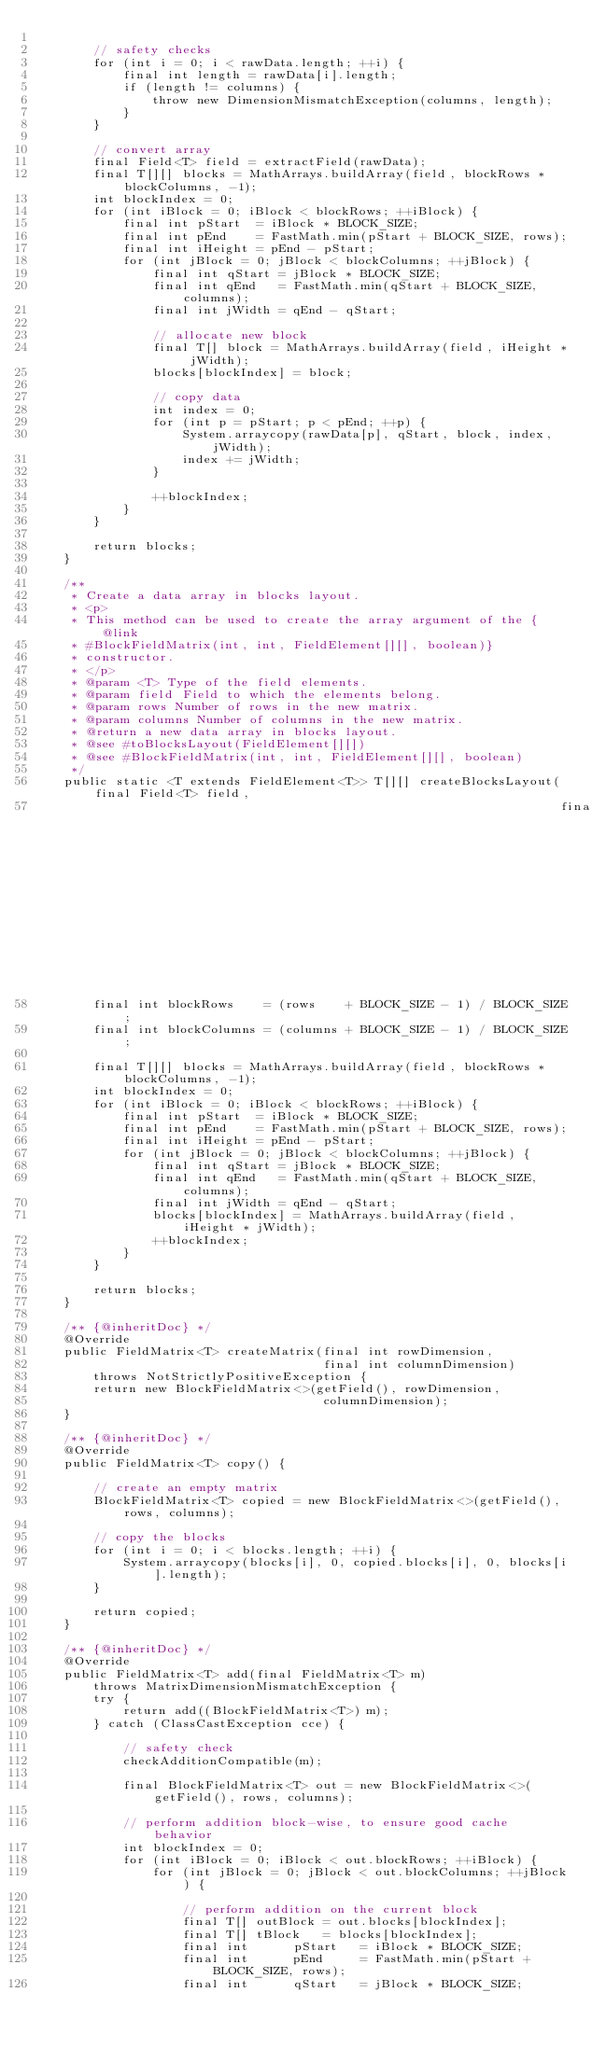<code> <loc_0><loc_0><loc_500><loc_500><_Java_>
        // safety checks
        for (int i = 0; i < rawData.length; ++i) {
            final int length = rawData[i].length;
            if (length != columns) {
                throw new DimensionMismatchException(columns, length);
            }
        }

        // convert array
        final Field<T> field = extractField(rawData);
        final T[][] blocks = MathArrays.buildArray(field, blockRows * blockColumns, -1);
        int blockIndex = 0;
        for (int iBlock = 0; iBlock < blockRows; ++iBlock) {
            final int pStart  = iBlock * BLOCK_SIZE;
            final int pEnd    = FastMath.min(pStart + BLOCK_SIZE, rows);
            final int iHeight = pEnd - pStart;
            for (int jBlock = 0; jBlock < blockColumns; ++jBlock) {
                final int qStart = jBlock * BLOCK_SIZE;
                final int qEnd   = FastMath.min(qStart + BLOCK_SIZE, columns);
                final int jWidth = qEnd - qStart;

                // allocate new block
                final T[] block = MathArrays.buildArray(field, iHeight * jWidth);
                blocks[blockIndex] = block;

                // copy data
                int index = 0;
                for (int p = pStart; p < pEnd; ++p) {
                    System.arraycopy(rawData[p], qStart, block, index, jWidth);
                    index += jWidth;
                }

                ++blockIndex;
            }
        }

        return blocks;
    }

    /**
     * Create a data array in blocks layout.
     * <p>
     * This method can be used to create the array argument of the {@link
     * #BlockFieldMatrix(int, int, FieldElement[][], boolean)}
     * constructor.
     * </p>
     * @param <T> Type of the field elements.
     * @param field Field to which the elements belong.
     * @param rows Number of rows in the new matrix.
     * @param columns Number of columns in the new matrix.
     * @return a new data array in blocks layout.
     * @see #toBlocksLayout(FieldElement[][])
     * @see #BlockFieldMatrix(int, int, FieldElement[][], boolean)
     */
    public static <T extends FieldElement<T>> T[][] createBlocksLayout(final Field<T> field,
                                                                       final int rows, final int columns) {
        final int blockRows    = (rows    + BLOCK_SIZE - 1) / BLOCK_SIZE;
        final int blockColumns = (columns + BLOCK_SIZE - 1) / BLOCK_SIZE;

        final T[][] blocks = MathArrays.buildArray(field, blockRows * blockColumns, -1);
        int blockIndex = 0;
        for (int iBlock = 0; iBlock < blockRows; ++iBlock) {
            final int pStart  = iBlock * BLOCK_SIZE;
            final int pEnd    = FastMath.min(pStart + BLOCK_SIZE, rows);
            final int iHeight = pEnd - pStart;
            for (int jBlock = 0; jBlock < blockColumns; ++jBlock) {
                final int qStart = jBlock * BLOCK_SIZE;
                final int qEnd   = FastMath.min(qStart + BLOCK_SIZE, columns);
                final int jWidth = qEnd - qStart;
                blocks[blockIndex] = MathArrays.buildArray(field, iHeight * jWidth);
                ++blockIndex;
            }
        }

        return blocks;
    }

    /** {@inheritDoc} */
    @Override
    public FieldMatrix<T> createMatrix(final int rowDimension,
                                       final int columnDimension)
        throws NotStrictlyPositiveException {
        return new BlockFieldMatrix<>(getField(), rowDimension,
                                       columnDimension);
    }

    /** {@inheritDoc} */
    @Override
    public FieldMatrix<T> copy() {

        // create an empty matrix
        BlockFieldMatrix<T> copied = new BlockFieldMatrix<>(getField(), rows, columns);

        // copy the blocks
        for (int i = 0; i < blocks.length; ++i) {
            System.arraycopy(blocks[i], 0, copied.blocks[i], 0, blocks[i].length);
        }

        return copied;
    }

    /** {@inheritDoc} */
    @Override
    public FieldMatrix<T> add(final FieldMatrix<T> m)
        throws MatrixDimensionMismatchException {
        try {
            return add((BlockFieldMatrix<T>) m);
        } catch (ClassCastException cce) {

            // safety check
            checkAdditionCompatible(m);

            final BlockFieldMatrix<T> out = new BlockFieldMatrix<>(getField(), rows, columns);

            // perform addition block-wise, to ensure good cache behavior
            int blockIndex = 0;
            for (int iBlock = 0; iBlock < out.blockRows; ++iBlock) {
                for (int jBlock = 0; jBlock < out.blockColumns; ++jBlock) {

                    // perform addition on the current block
                    final T[] outBlock = out.blocks[blockIndex];
                    final T[] tBlock   = blocks[blockIndex];
                    final int      pStart   = iBlock * BLOCK_SIZE;
                    final int      pEnd     = FastMath.min(pStart + BLOCK_SIZE, rows);
                    final int      qStart   = jBlock * BLOCK_SIZE;</code> 